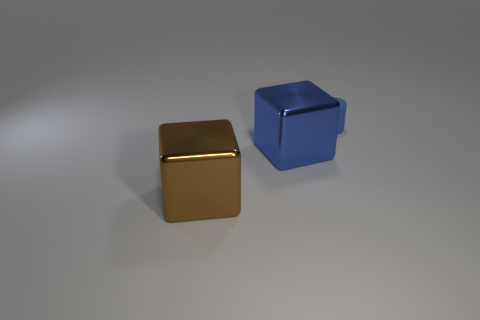Subtract all cubes. How many objects are left? 1 Add 1 brown blocks. How many objects exist? 4 Add 1 big blue cubes. How many big blue cubes exist? 2 Subtract 0 red blocks. How many objects are left? 3 Subtract all small blue objects. Subtract all big brown metallic things. How many objects are left? 1 Add 3 tiny blue rubber things. How many tiny blue rubber things are left? 4 